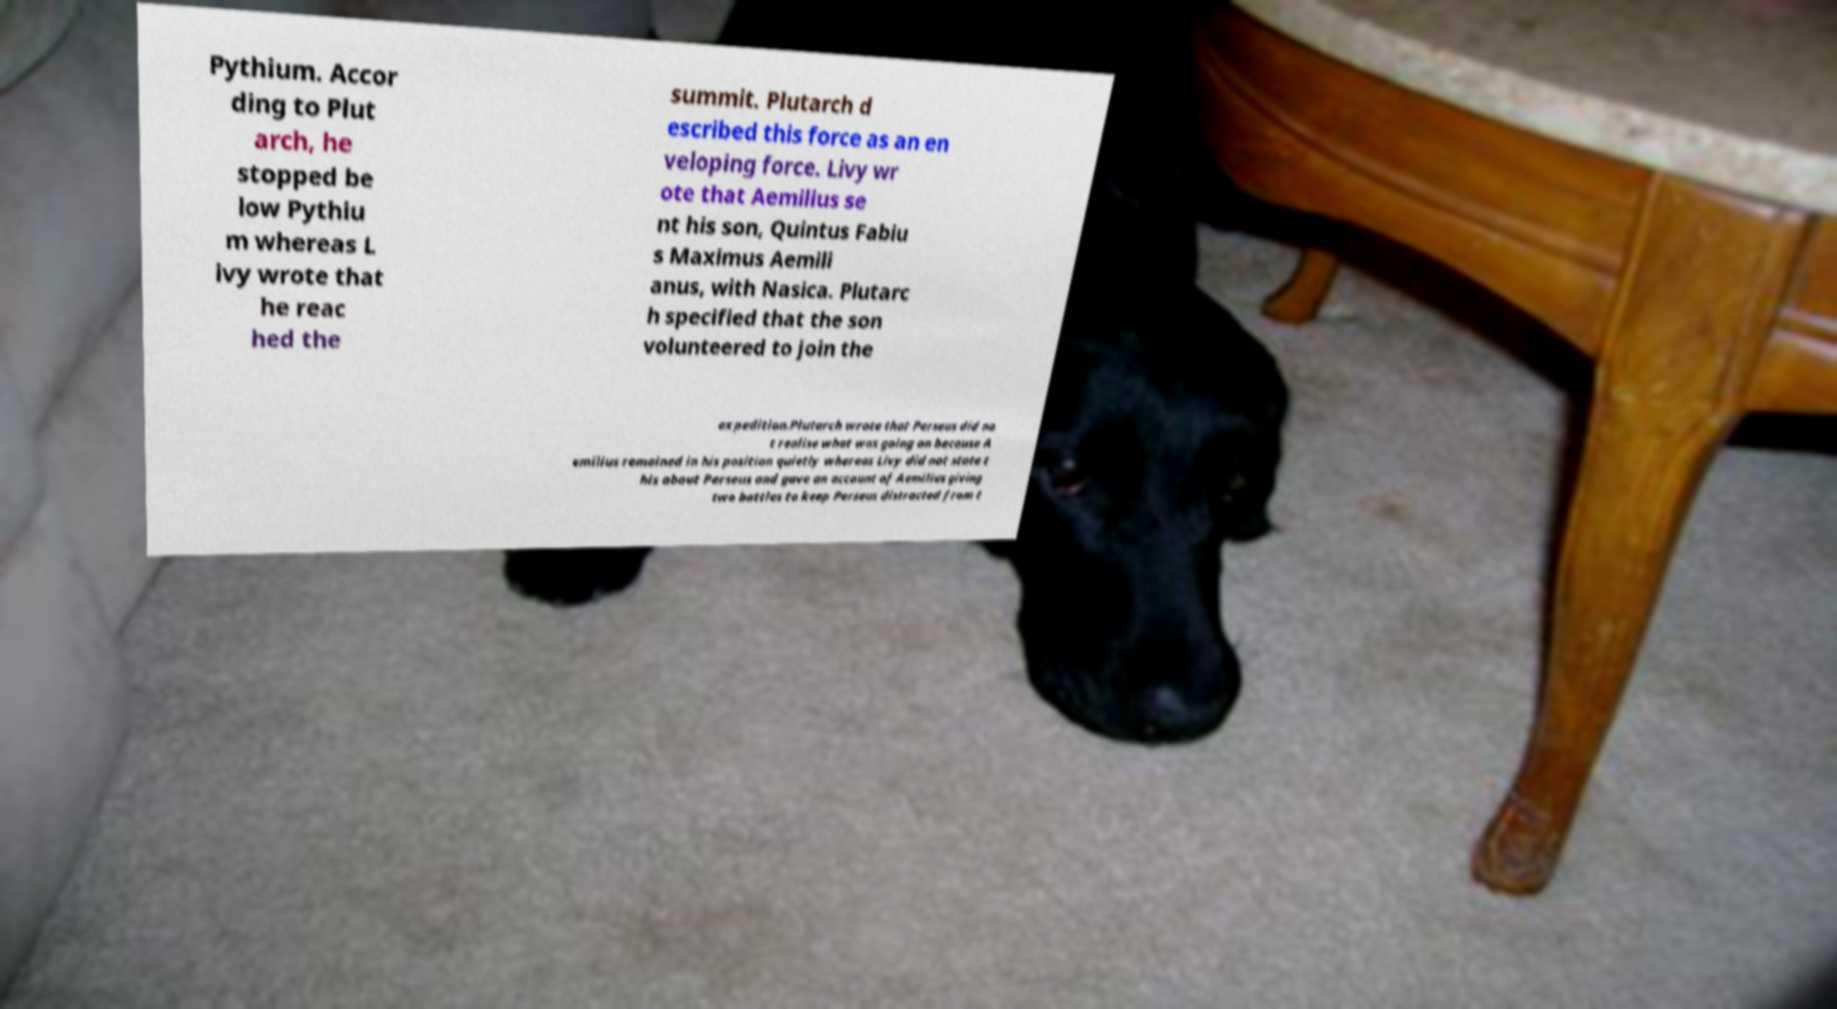Please read and relay the text visible in this image. What does it say? Pythium. Accor ding to Plut arch, he stopped be low Pythiu m whereas L ivy wrote that he reac hed the summit. Plutarch d escribed this force as an en veloping force. Livy wr ote that Aemilius se nt his son, Quintus Fabiu s Maximus Aemili anus, with Nasica. Plutarc h specified that the son volunteered to join the expedition.Plutarch wrote that Perseus did no t realise what was going on because A emilius remained in his position quietly whereas Livy did not state t his about Perseus and gave an account of Aemilius giving two battles to keep Perseus distracted from t 